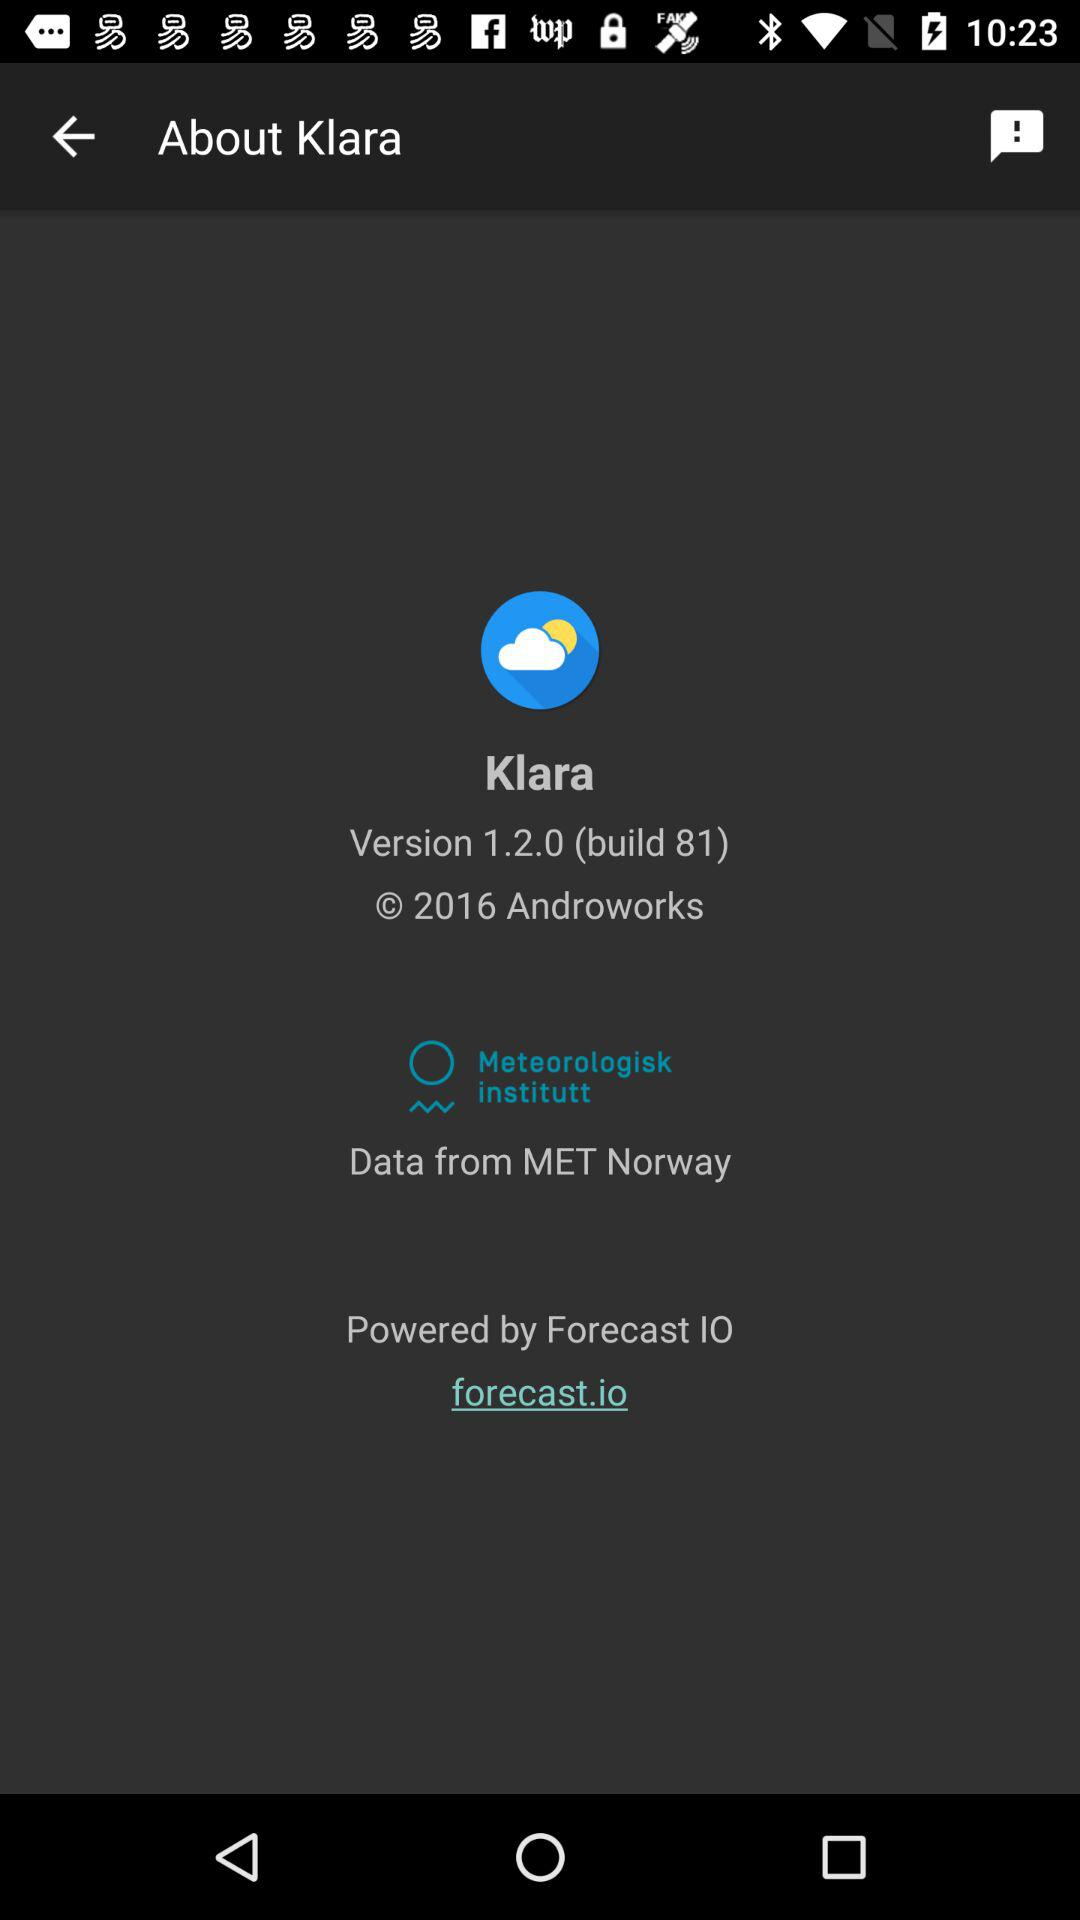From where does the application fetch data? The application fetches data from MET Norway. 